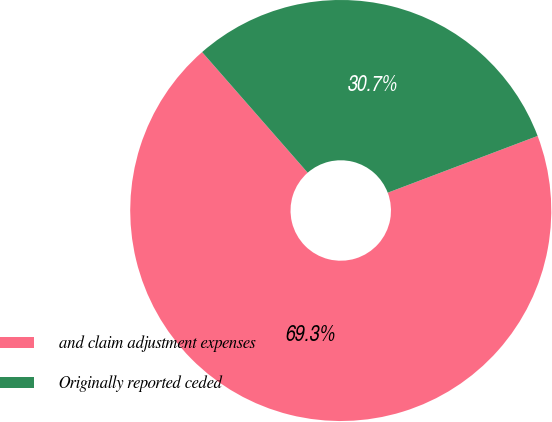<chart> <loc_0><loc_0><loc_500><loc_500><pie_chart><fcel>and claim adjustment expenses<fcel>Originally reported ceded<nl><fcel>69.32%<fcel>30.68%<nl></chart> 